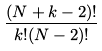Convert formula to latex. <formula><loc_0><loc_0><loc_500><loc_500>\frac { ( N + k - 2 ) ! } { k ! ( N - 2 ) ! }</formula> 